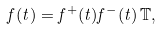Convert formula to latex. <formula><loc_0><loc_0><loc_500><loc_500>f ( t ) = f ^ { + } ( t ) f ^ { - } ( t ) \, \mathbb { T } ,</formula> 